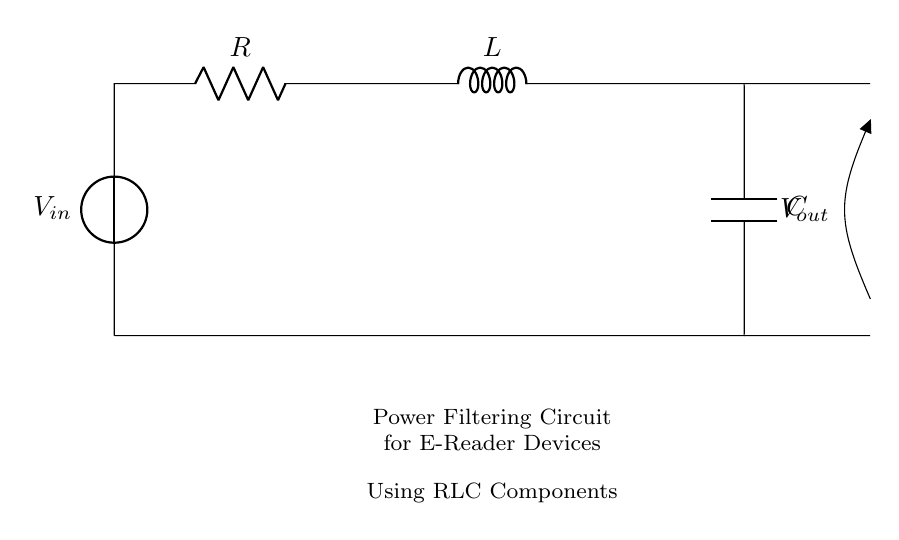What are the components present in this circuit? The circuit contains a voltage source, a resistor, an inductor, and a capacitor. These can be identified by their symbols in the diagram.
Answer: Voltage source, resistor, inductor, capacitor What is the voltage across the output? The output voltage is indicated as V out, which is shown after the load components. Since there are no specific values given, it represents the output voltage generated by the circuit.
Answer: V out How many energy storage elements are in this circuit? There are two energy storage elements: the inductor and the capacitor. The inductor stores energy in its magnetic field, and the capacitor stores energy in its electric field.
Answer: Two What is the function of the resistor in this circuit? The resistor serves to limit current and dissipate energy as heat, regulating the power flow to the inductor and capacitor. This helps in controlling the circuit's performance.
Answer: Limit current What kind of filter can this RLC circuit serve as? This RLC circuit can operate as a low-pass filter, allowing low-frequency signals to pass while attenuating high-frequency signals. The behavior is determined by the combination of R, L, and C values.
Answer: Low-pass filter How does the presence of the inductor affect the circuit's behavior? The inductor introduces reactance, which influences the impedance of the circuit. At higher frequencies, the inductor's reactance increases, which affects the response of the power filtering for e-reader devices.
Answer: Introduces reactance 